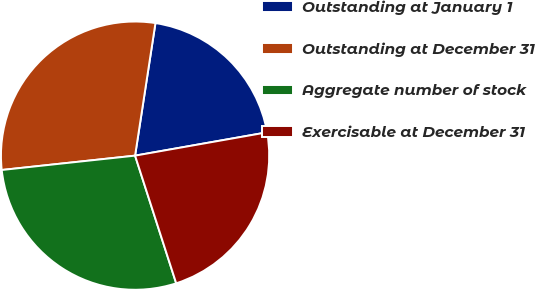Convert chart. <chart><loc_0><loc_0><loc_500><loc_500><pie_chart><fcel>Outstanding at January 1<fcel>Outstanding at December 31<fcel>Aggregate number of stock<fcel>Exercisable at December 31<nl><fcel>19.79%<fcel>29.13%<fcel>28.25%<fcel>22.82%<nl></chart> 